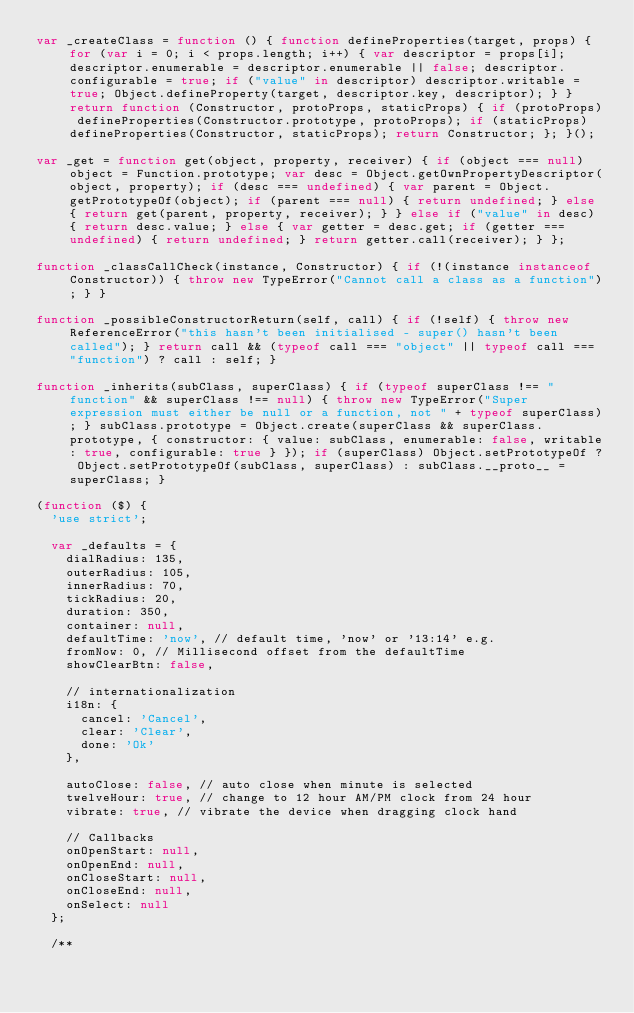Convert code to text. <code><loc_0><loc_0><loc_500><loc_500><_JavaScript_>var _createClass = function () { function defineProperties(target, props) { for (var i = 0; i < props.length; i++) { var descriptor = props[i]; descriptor.enumerable = descriptor.enumerable || false; descriptor.configurable = true; if ("value" in descriptor) descriptor.writable = true; Object.defineProperty(target, descriptor.key, descriptor); } } return function (Constructor, protoProps, staticProps) { if (protoProps) defineProperties(Constructor.prototype, protoProps); if (staticProps) defineProperties(Constructor, staticProps); return Constructor; }; }();

var _get = function get(object, property, receiver) { if (object === null) object = Function.prototype; var desc = Object.getOwnPropertyDescriptor(object, property); if (desc === undefined) { var parent = Object.getPrototypeOf(object); if (parent === null) { return undefined; } else { return get(parent, property, receiver); } } else if ("value" in desc) { return desc.value; } else { var getter = desc.get; if (getter === undefined) { return undefined; } return getter.call(receiver); } };

function _classCallCheck(instance, Constructor) { if (!(instance instanceof Constructor)) { throw new TypeError("Cannot call a class as a function"); } }

function _possibleConstructorReturn(self, call) { if (!self) { throw new ReferenceError("this hasn't been initialised - super() hasn't been called"); } return call && (typeof call === "object" || typeof call === "function") ? call : self; }

function _inherits(subClass, superClass) { if (typeof superClass !== "function" && superClass !== null) { throw new TypeError("Super expression must either be null or a function, not " + typeof superClass); } subClass.prototype = Object.create(superClass && superClass.prototype, { constructor: { value: subClass, enumerable: false, writable: true, configurable: true } }); if (superClass) Object.setPrototypeOf ? Object.setPrototypeOf(subClass, superClass) : subClass.__proto__ = superClass; }

(function ($) {
  'use strict';

  var _defaults = {
    dialRadius: 135,
    outerRadius: 105,
    innerRadius: 70,
    tickRadius: 20,
    duration: 350,
    container: null,
    defaultTime: 'now', // default time, 'now' or '13:14' e.g.
    fromNow: 0, // Millisecond offset from the defaultTime
    showClearBtn: false,

    // internationalization
    i18n: {
      cancel: 'Cancel',
      clear: 'Clear',
      done: 'Ok'
    },

    autoClose: false, // auto close when minute is selected
    twelveHour: true, // change to 12 hour AM/PM clock from 24 hour
    vibrate: true, // vibrate the device when dragging clock hand

    // Callbacks
    onOpenStart: null,
    onOpenEnd: null,
    onCloseStart: null,
    onCloseEnd: null,
    onSelect: null
  };

  /**</code> 